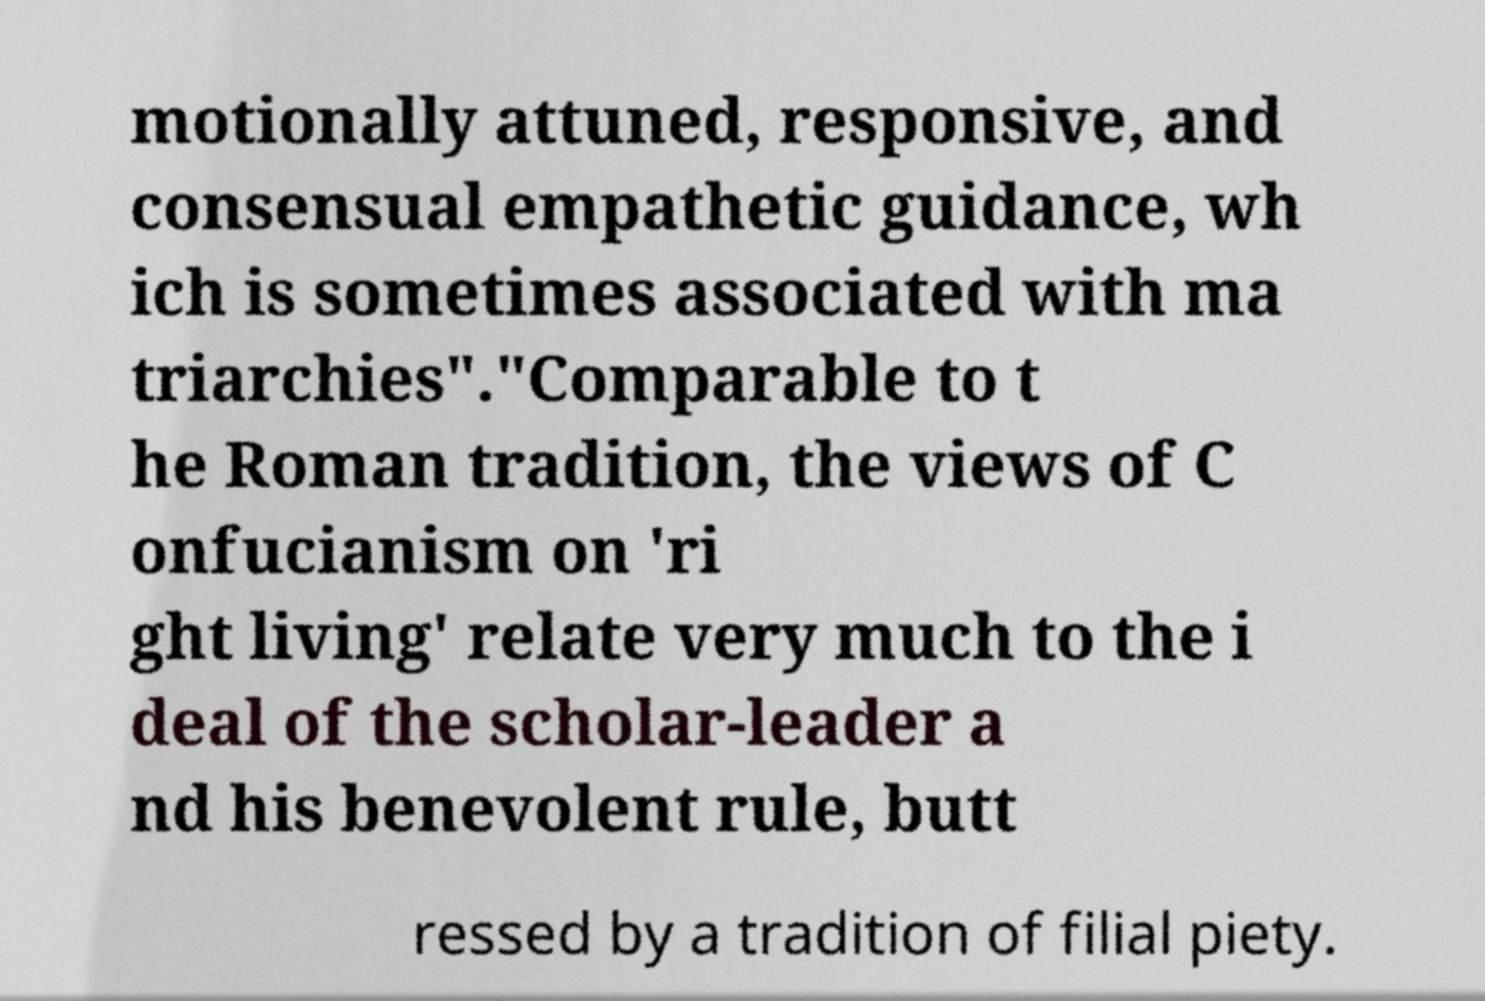There's text embedded in this image that I need extracted. Can you transcribe it verbatim? motionally attuned, responsive, and consensual empathetic guidance, wh ich is sometimes associated with ma triarchies"."Comparable to t he Roman tradition, the views of C onfucianism on 'ri ght living' relate very much to the i deal of the scholar-leader a nd his benevolent rule, butt ressed by a tradition of filial piety. 